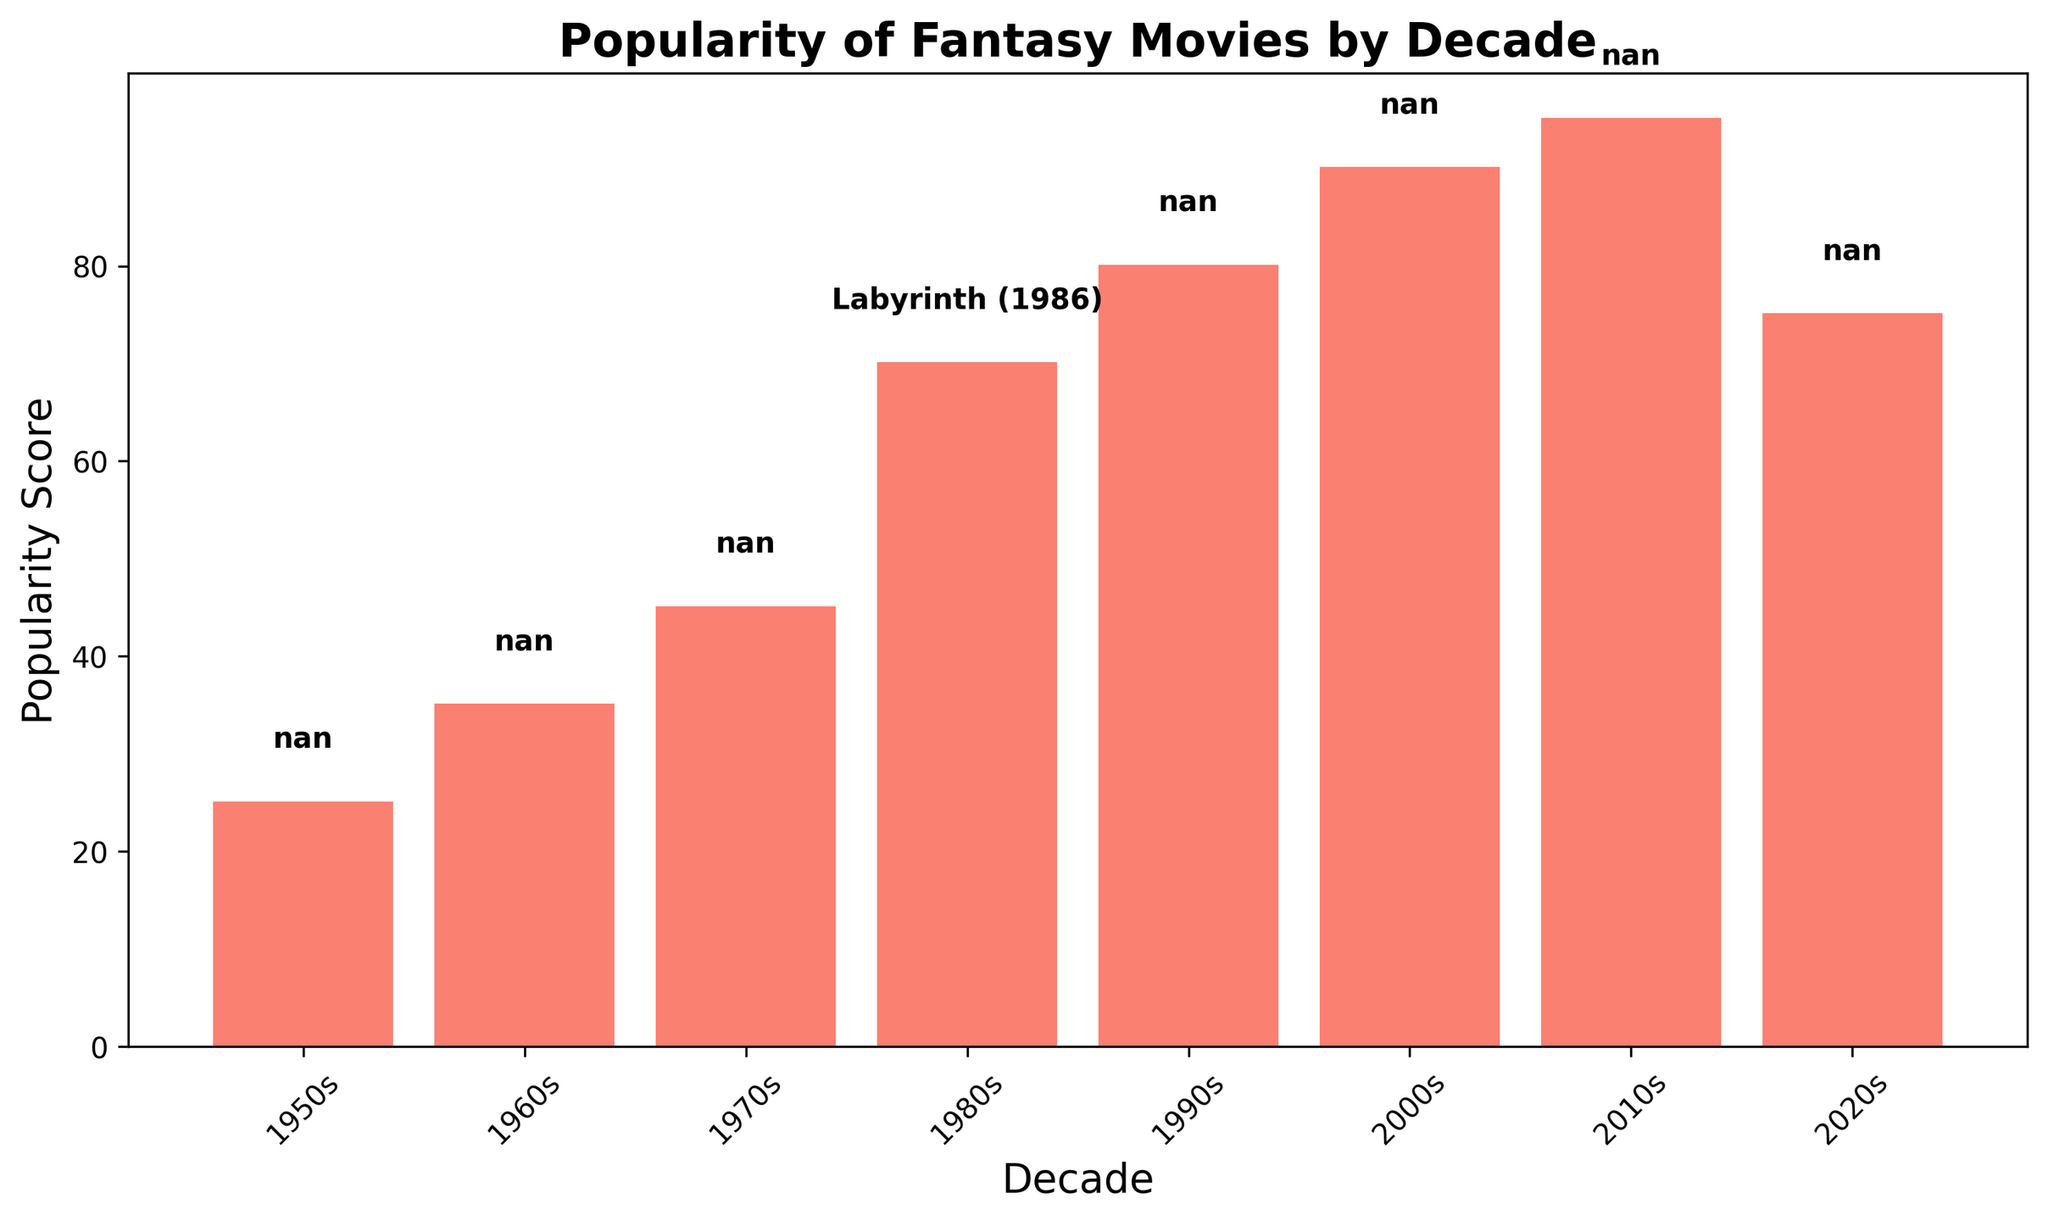What is the difference in popularity scores between the 1980s and 1990s decades? The popularity score for the 1980s is 70, and for the 1990s, it is 80. The difference is 80 - 70 = 10.
Answer: 10 Which decade has the highest popularity score for fantasy movies? The decade with the highest bar is the 2010s, with a popularity score of 95.
Answer: 2010s Between which two consecutive decades does the popularity score see the biggest increase? Comparing each pair of consecutive decades: 1960s to 1950s (+10), 1970s to 1960s (+10), 1980s to 1970s (+25), 1990s to 1980s (+10), 2000s to 1990s (+10), 2010s to 2000s (+5), and 2020s to 2010s (-20). The biggest increase is from the 1970s to the 1980s (+25).
Answer: 1970s to 1980s What is the average popularity score across all decades? Sum all popularity scores: 25 + 35 + 45 + 70 + 80 + 90 + 95 + 75 = 515. There are 8 decades. The average is 515/8 = 64.375.
Answer: 64.38 Which decade has a lower popularity score than the 1980s but higher than the 1960s? The 1980s has a score of 70, and the 1960s has a score of 35. The 1970s, with a score of 45, fits this criterion.
Answer: 1970s Is "Labyrinth (1986)" in the decade with the highest popularity score? "Labyrinth (1986)" is highlighted in the 1980s decade, which has a popularity score of 70. However, the highest popularity score is in the 2010s with a score of 95.
Answer: No What is the median popularity score of the fantasy movies by decade? Arrange the scores in ascending order: 25, 35, 45, 70, 75, 80, 90, 95. With 8 scores, the median is the average of the 4th and 5th scores. (70 + 75)/2 = 72.5
Answer: 72.5 Which decade displays a highlighted movie, and what is the popularity score for that decade? The highlighted movie "Labyrinth (1986)" is in the 1980s decade, with a popularity score of 70.
Answer: 1980s, 70 When did the popularity of fantasy movies first exceed 50? The popularity score first exceeds 50 in the decade of the 1980s, with a score of 70.
Answer: 1980s 